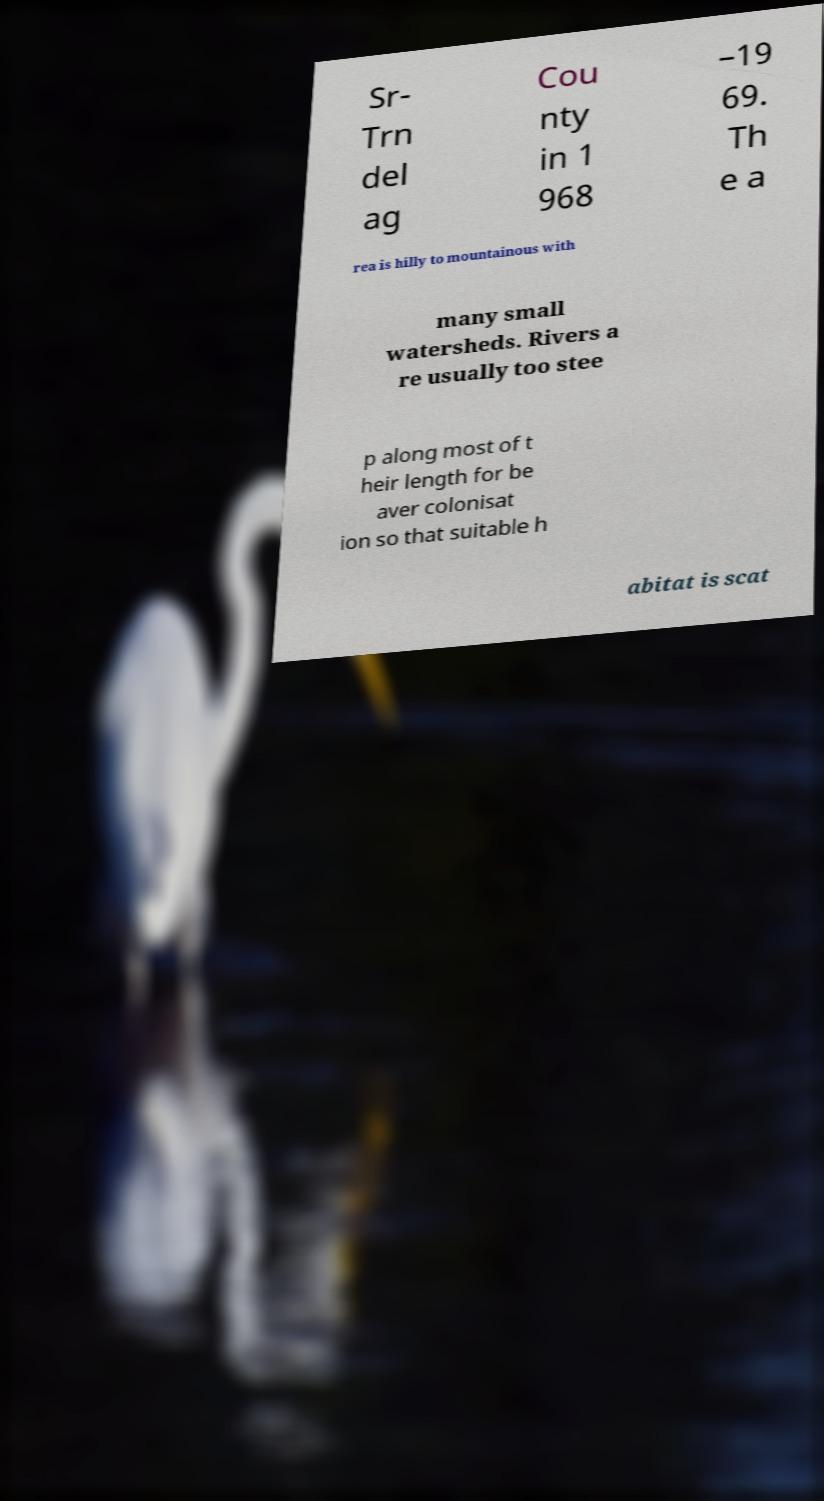Could you assist in decoding the text presented in this image and type it out clearly? Sr- Trn del ag Cou nty in 1 968 –19 69. Th e a rea is hilly to mountainous with many small watersheds. Rivers a re usually too stee p along most of t heir length for be aver colonisat ion so that suitable h abitat is scat 